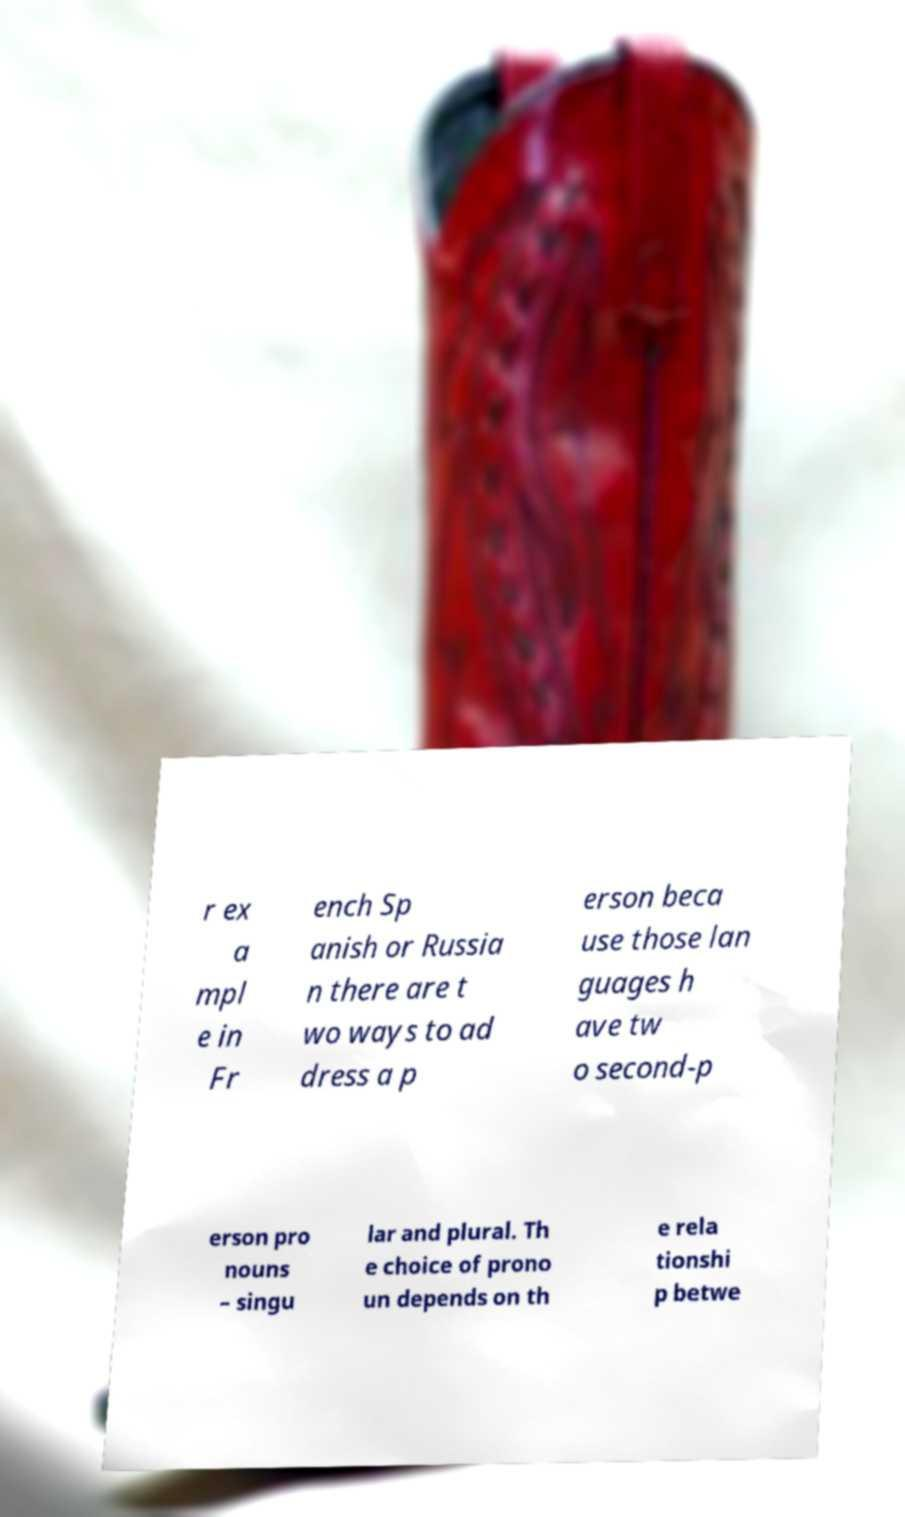Can you accurately transcribe the text from the provided image for me? r ex a mpl e in Fr ench Sp anish or Russia n there are t wo ways to ad dress a p erson beca use those lan guages h ave tw o second-p erson pro nouns – singu lar and plural. Th e choice of prono un depends on th e rela tionshi p betwe 